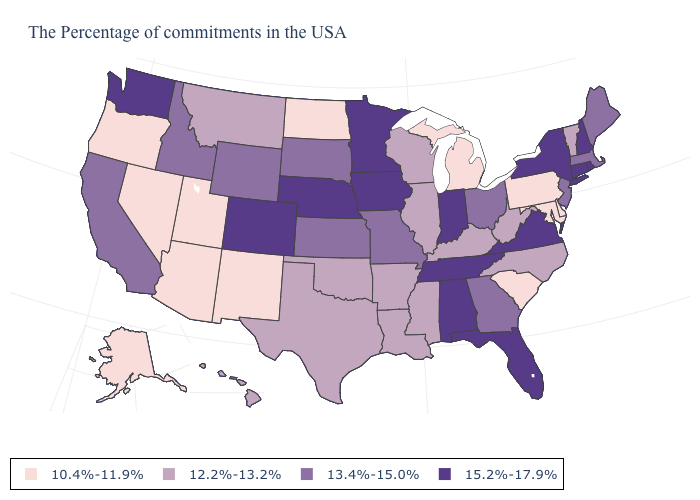What is the highest value in the West ?
Answer briefly. 15.2%-17.9%. What is the value of Ohio?
Concise answer only. 13.4%-15.0%. Does Arizona have the lowest value in the West?
Be succinct. Yes. Does Oregon have the highest value in the West?
Short answer required. No. What is the value of California?
Be succinct. 13.4%-15.0%. Does Delaware have the lowest value in the South?
Write a very short answer. Yes. What is the lowest value in the South?
Keep it brief. 10.4%-11.9%. Does Alabama have the highest value in the USA?
Write a very short answer. Yes. Does Louisiana have the same value as Montana?
Concise answer only. Yes. Name the states that have a value in the range 15.2%-17.9%?
Write a very short answer. Rhode Island, New Hampshire, Connecticut, New York, Virginia, Florida, Indiana, Alabama, Tennessee, Minnesota, Iowa, Nebraska, Colorado, Washington. Name the states that have a value in the range 12.2%-13.2%?
Write a very short answer. Vermont, North Carolina, West Virginia, Kentucky, Wisconsin, Illinois, Mississippi, Louisiana, Arkansas, Oklahoma, Texas, Montana, Hawaii. What is the value of Washington?
Write a very short answer. 15.2%-17.9%. What is the highest value in the South ?
Write a very short answer. 15.2%-17.9%. What is the value of Maine?
Short answer required. 13.4%-15.0%. What is the value of Washington?
Short answer required. 15.2%-17.9%. 